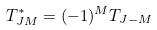<formula> <loc_0><loc_0><loc_500><loc_500>T ^ { * } _ { J M } = ( - 1 ) ^ { M } T _ { J - M }</formula> 